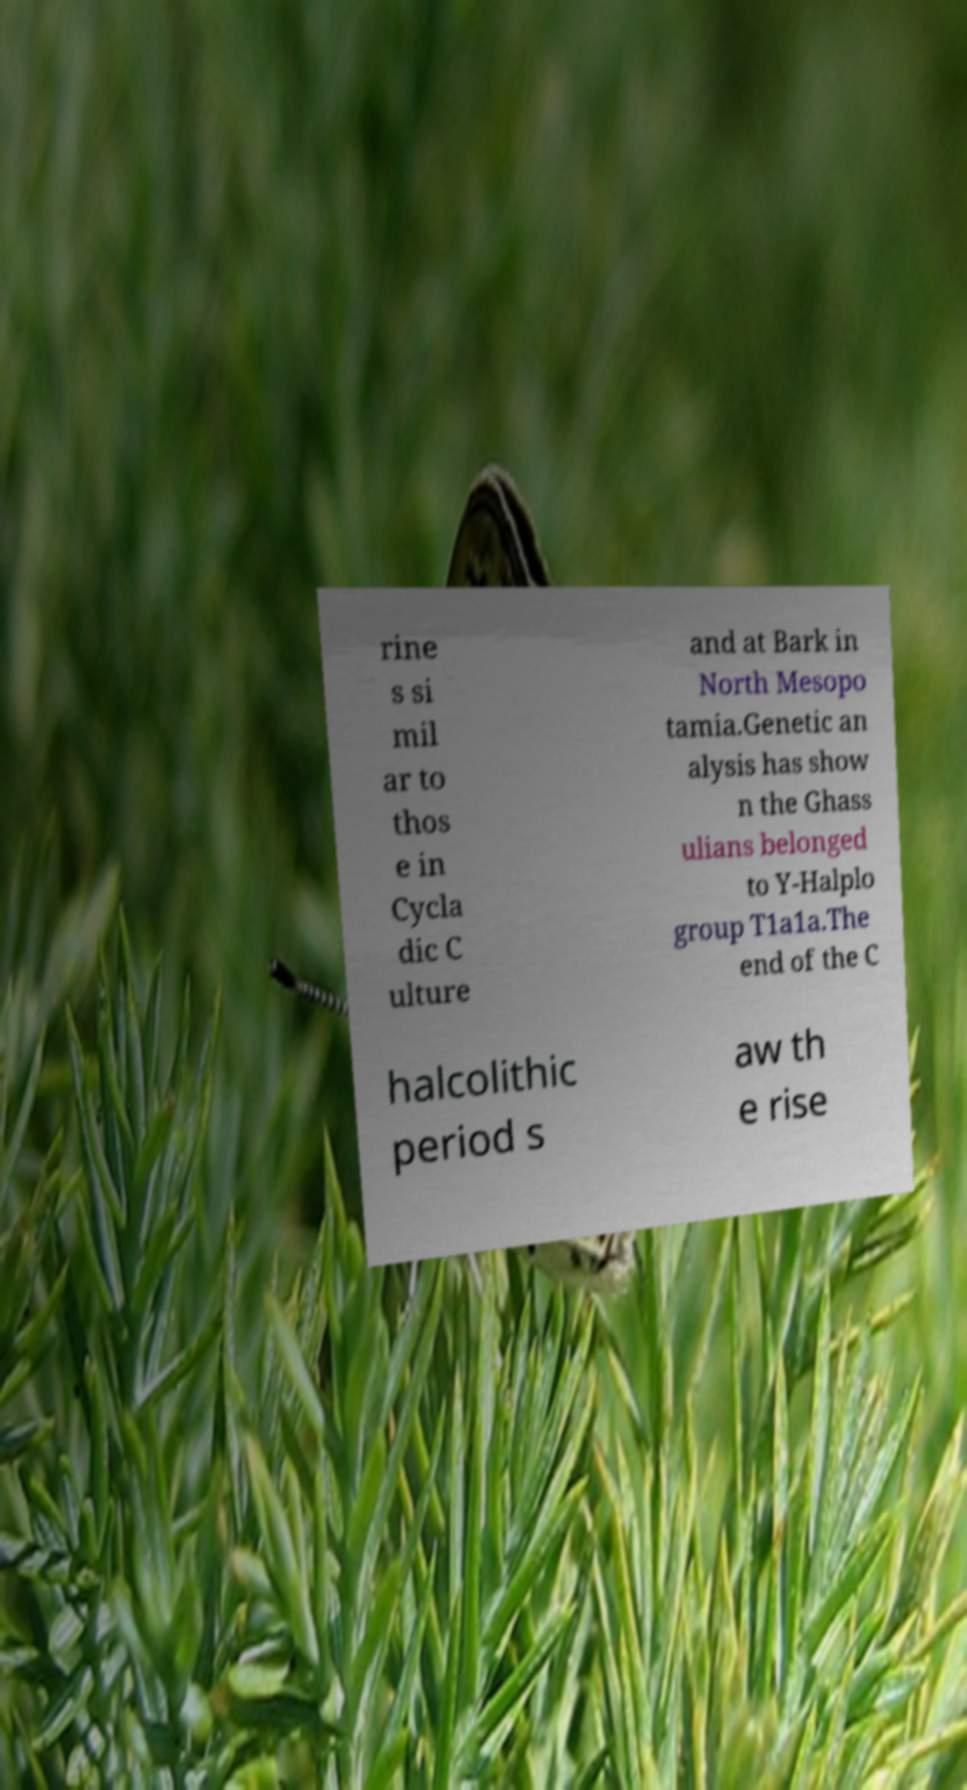Please identify and transcribe the text found in this image. rine s si mil ar to thos e in Cycla dic C ulture and at Bark in North Mesopo tamia.Genetic an alysis has show n the Ghass ulians belonged to Y-Halplo group T1a1a.The end of the C halcolithic period s aw th e rise 